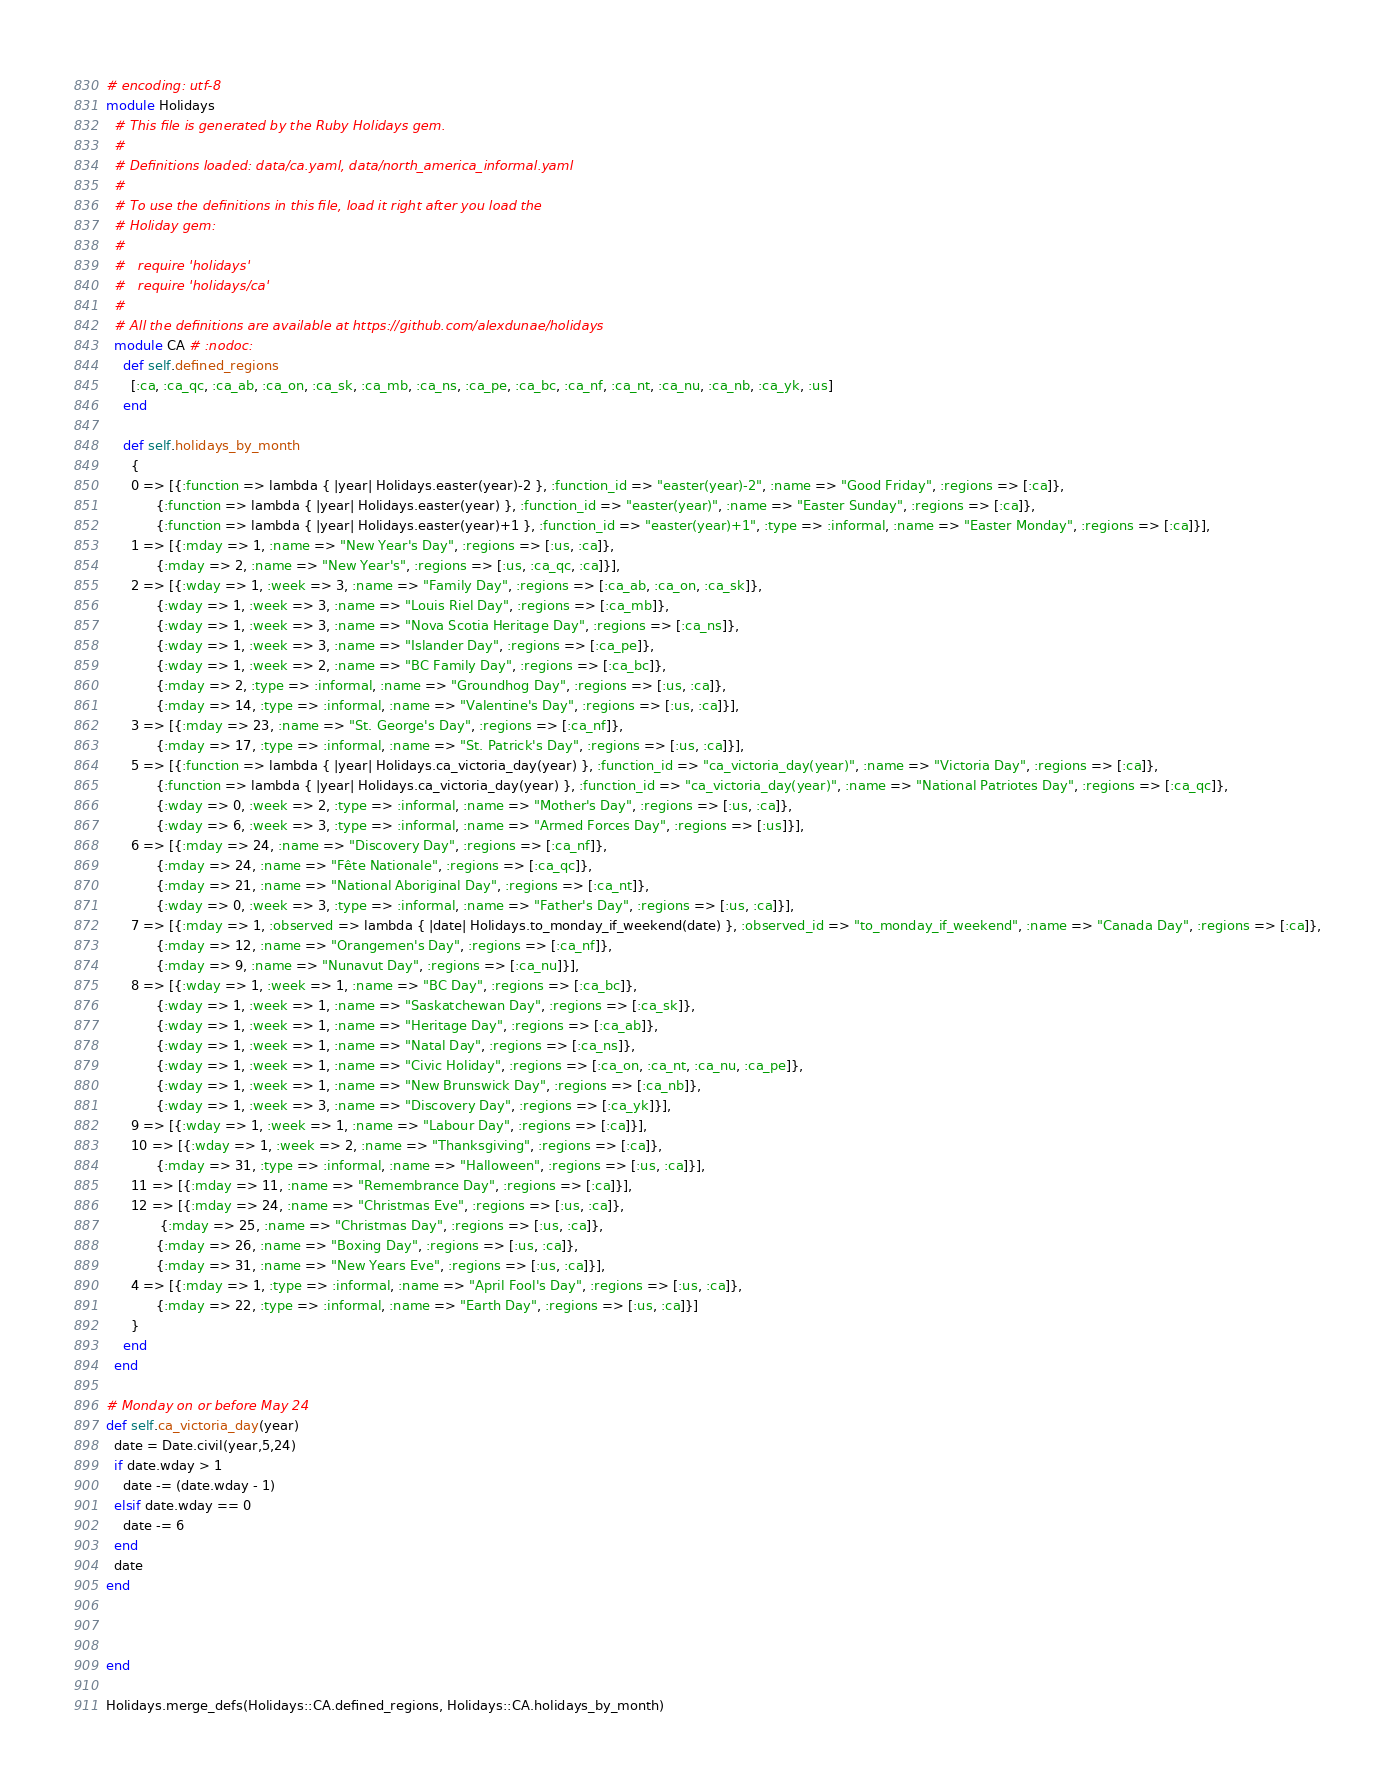<code> <loc_0><loc_0><loc_500><loc_500><_Ruby_># encoding: utf-8
module Holidays
  # This file is generated by the Ruby Holidays gem.
  #
  # Definitions loaded: data/ca.yaml, data/north_america_informal.yaml
  #
  # To use the definitions in this file, load it right after you load the
  # Holiday gem:
  #
  #   require 'holidays'
  #   require 'holidays/ca'
  #
  # All the definitions are available at https://github.com/alexdunae/holidays
  module CA # :nodoc:
    def self.defined_regions
      [:ca, :ca_qc, :ca_ab, :ca_on, :ca_sk, :ca_mb, :ca_ns, :ca_pe, :ca_bc, :ca_nf, :ca_nt, :ca_nu, :ca_nb, :ca_yk, :us]
    end

    def self.holidays_by_month
      {
      0 => [{:function => lambda { |year| Holidays.easter(year)-2 }, :function_id => "easter(year)-2", :name => "Good Friday", :regions => [:ca]},
            {:function => lambda { |year| Holidays.easter(year) }, :function_id => "easter(year)", :name => "Easter Sunday", :regions => [:ca]},
            {:function => lambda { |year| Holidays.easter(year)+1 }, :function_id => "easter(year)+1", :type => :informal, :name => "Easter Monday", :regions => [:ca]}],
      1 => [{:mday => 1, :name => "New Year's Day", :regions => [:us, :ca]},
            {:mday => 2, :name => "New Year's", :regions => [:us, :ca_qc, :ca]}],
      2 => [{:wday => 1, :week => 3, :name => "Family Day", :regions => [:ca_ab, :ca_on, :ca_sk]},
            {:wday => 1, :week => 3, :name => "Louis Riel Day", :regions => [:ca_mb]},
            {:wday => 1, :week => 3, :name => "Nova Scotia Heritage Day", :regions => [:ca_ns]},
            {:wday => 1, :week => 3, :name => "Islander Day", :regions => [:ca_pe]},
            {:wday => 1, :week => 2, :name => "BC Family Day", :regions => [:ca_bc]},
            {:mday => 2, :type => :informal, :name => "Groundhog Day", :regions => [:us, :ca]},
            {:mday => 14, :type => :informal, :name => "Valentine's Day", :regions => [:us, :ca]}],
      3 => [{:mday => 23, :name => "St. George's Day", :regions => [:ca_nf]},
            {:mday => 17, :type => :informal, :name => "St. Patrick's Day", :regions => [:us, :ca]}],
      5 => [{:function => lambda { |year| Holidays.ca_victoria_day(year) }, :function_id => "ca_victoria_day(year)", :name => "Victoria Day", :regions => [:ca]},
            {:function => lambda { |year| Holidays.ca_victoria_day(year) }, :function_id => "ca_victoria_day(year)", :name => "National Patriotes Day", :regions => [:ca_qc]},
            {:wday => 0, :week => 2, :type => :informal, :name => "Mother's Day", :regions => [:us, :ca]},
            {:wday => 6, :week => 3, :type => :informal, :name => "Armed Forces Day", :regions => [:us]}],
      6 => [{:mday => 24, :name => "Discovery Day", :regions => [:ca_nf]},
            {:mday => 24, :name => "Fête Nationale", :regions => [:ca_qc]},
            {:mday => 21, :name => "National Aboriginal Day", :regions => [:ca_nt]},
            {:wday => 0, :week => 3, :type => :informal, :name => "Father's Day", :regions => [:us, :ca]}],
      7 => [{:mday => 1, :observed => lambda { |date| Holidays.to_monday_if_weekend(date) }, :observed_id => "to_monday_if_weekend", :name => "Canada Day", :regions => [:ca]},
            {:mday => 12, :name => "Orangemen's Day", :regions => [:ca_nf]},
            {:mday => 9, :name => "Nunavut Day", :regions => [:ca_nu]}],
      8 => [{:wday => 1, :week => 1, :name => "BC Day", :regions => [:ca_bc]},
            {:wday => 1, :week => 1, :name => "Saskatchewan Day", :regions => [:ca_sk]},
            {:wday => 1, :week => 1, :name => "Heritage Day", :regions => [:ca_ab]},
            {:wday => 1, :week => 1, :name => "Natal Day", :regions => [:ca_ns]},
            {:wday => 1, :week => 1, :name => "Civic Holiday", :regions => [:ca_on, :ca_nt, :ca_nu, :ca_pe]},
            {:wday => 1, :week => 1, :name => "New Brunswick Day", :regions => [:ca_nb]},
            {:wday => 1, :week => 3, :name => "Discovery Day", :regions => [:ca_yk]}],
      9 => [{:wday => 1, :week => 1, :name => "Labour Day", :regions => [:ca]}],
      10 => [{:wday => 1, :week => 2, :name => "Thanksgiving", :regions => [:ca]},
            {:mday => 31, :type => :informal, :name => "Halloween", :regions => [:us, :ca]}],
      11 => [{:mday => 11, :name => "Remembrance Day", :regions => [:ca]}],
      12 => [{:mday => 24, :name => "Christmas Eve", :regions => [:us, :ca]},
             {:mday => 25, :name => "Christmas Day", :regions => [:us, :ca]},
            {:mday => 26, :name => "Boxing Day", :regions => [:us, :ca]},
            {:mday => 31, :name => "New Years Eve", :regions => [:us, :ca]}],
      4 => [{:mday => 1, :type => :informal, :name => "April Fool's Day", :regions => [:us, :ca]},
            {:mday => 22, :type => :informal, :name => "Earth Day", :regions => [:us, :ca]}]
      }
    end
  end

# Monday on or before May 24
def self.ca_victoria_day(year)
  date = Date.civil(year,5,24)
  if date.wday > 1
    date -= (date.wday - 1)
  elsif date.wday == 0
    date -= 6
  end
  date
end



end

Holidays.merge_defs(Holidays::CA.defined_regions, Holidays::CA.holidays_by_month)
</code> 